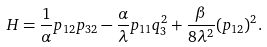<formula> <loc_0><loc_0><loc_500><loc_500>H = \frac { 1 } { \alpha } p _ { 1 2 } p _ { 3 2 } - \frac { \alpha } { \lambda } p _ { 1 1 } q _ { 3 } ^ { 2 } + \frac { \beta } { 8 \lambda ^ { 2 } } ( p _ { 1 2 } ) ^ { 2 } .</formula> 